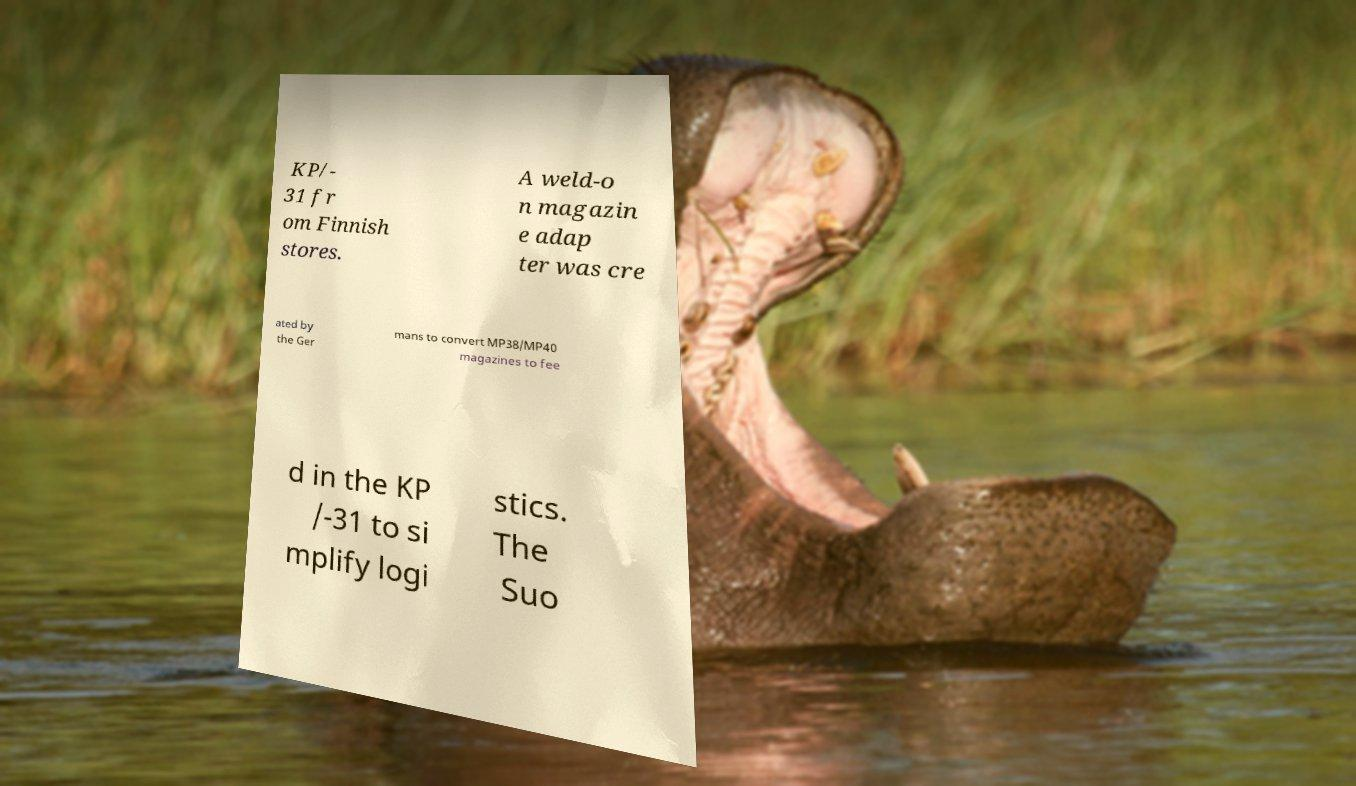Please read and relay the text visible in this image. What does it say? KP/- 31 fr om Finnish stores. A weld-o n magazin e adap ter was cre ated by the Ger mans to convert MP38/MP40 magazines to fee d in the KP /-31 to si mplify logi stics. The Suo 